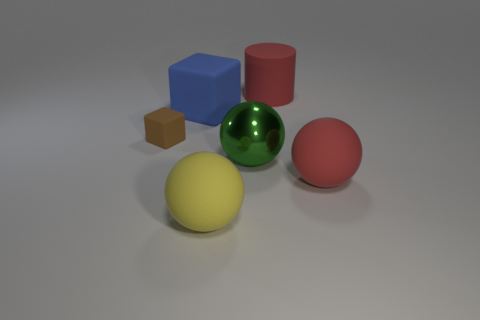Are there any other things that have the same color as the large metallic object?
Keep it short and to the point. No. What color is the rubber thing that is in front of the ball that is on the right side of the large metal ball?
Your answer should be compact. Yellow. Are there fewer big matte things that are in front of the big cube than green shiny spheres that are behind the large yellow ball?
Offer a very short reply. No. There is a ball that is the same color as the large cylinder; what is it made of?
Provide a succinct answer. Rubber. What number of objects are objects that are right of the large cube or tiny brown rubber cubes?
Provide a short and direct response. 5. There is a matte object to the right of the cylinder; is it the same size as the large green ball?
Provide a succinct answer. Yes. Are there fewer large blue cubes that are on the right side of the big blue matte object than red rubber spheres?
Provide a succinct answer. Yes. There is a blue cube that is the same size as the yellow rubber sphere; what material is it?
Offer a terse response. Rubber. How many large things are matte cubes or red balls?
Offer a very short reply. 2. What number of objects are things behind the big red rubber ball or large things that are on the right side of the yellow object?
Ensure brevity in your answer.  5. 